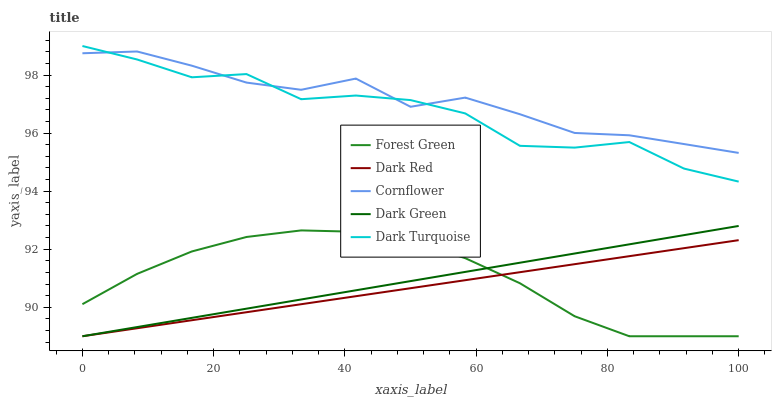Does Dark Red have the minimum area under the curve?
Answer yes or no. Yes. Does Cornflower have the maximum area under the curve?
Answer yes or no. Yes. Does Forest Green have the minimum area under the curve?
Answer yes or no. No. Does Forest Green have the maximum area under the curve?
Answer yes or no. No. Is Dark Red the smoothest?
Answer yes or no. Yes. Is Dark Turquoise the roughest?
Answer yes or no. Yes. Is Forest Green the smoothest?
Answer yes or no. No. Is Forest Green the roughest?
Answer yes or no. No. Does Dark Red have the lowest value?
Answer yes or no. Yes. Does Dark Turquoise have the lowest value?
Answer yes or no. No. Does Dark Turquoise have the highest value?
Answer yes or no. Yes. Does Forest Green have the highest value?
Answer yes or no. No. Is Dark Green less than Dark Turquoise?
Answer yes or no. Yes. Is Cornflower greater than Dark Green?
Answer yes or no. Yes. Does Dark Red intersect Dark Green?
Answer yes or no. Yes. Is Dark Red less than Dark Green?
Answer yes or no. No. Is Dark Red greater than Dark Green?
Answer yes or no. No. Does Dark Green intersect Dark Turquoise?
Answer yes or no. No. 